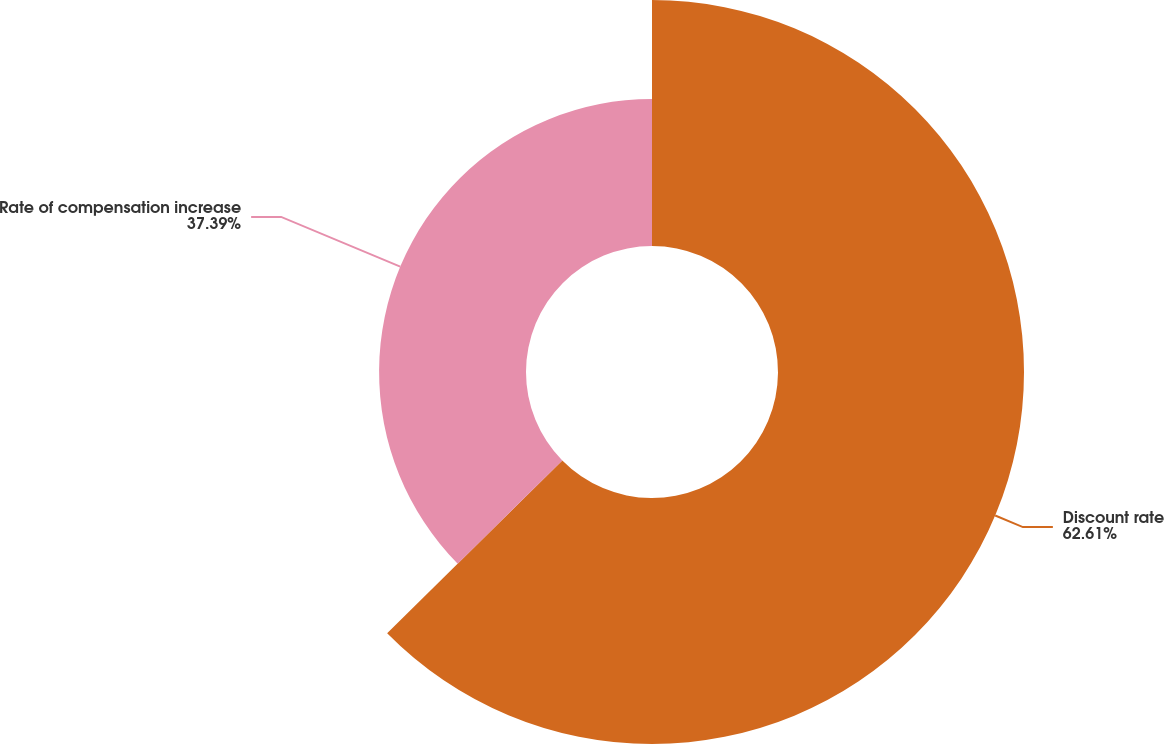<chart> <loc_0><loc_0><loc_500><loc_500><pie_chart><fcel>Discount rate<fcel>Rate of compensation increase<nl><fcel>62.61%<fcel>37.39%<nl></chart> 